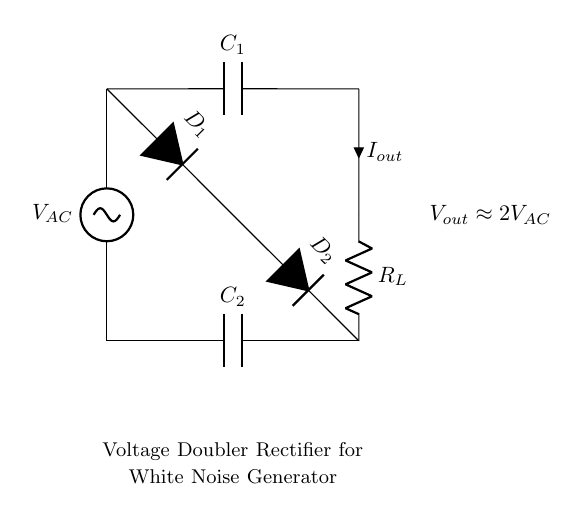What is the type of circuit represented? The circuit diagram shows a voltage doubler rectifier, which is designed to convert AC voltage to a higher DC voltage. The presence of capacitors and diodes with dual outputs indicates it's a specific type of rectifier that typically doubles the AC input voltage.
Answer: Voltage doubler rectifier What is the output voltage approximation? The output voltage is labeled as approximately twice the AC input voltage. This is derived from the function of the voltage doubler which, in ideal conditions, doubles the input voltage; hence, it is shown as two times the input AC voltage.
Answer: 2 times V AC How many capacitors are in the circuit? The circuit diagram contains two capacitors, labeled C1 and C2. Each capacitor serves a distinct purpose in the voltage doubling process, one connected to the output side and the other to the ground side of the circuit.
Answer: 2 What is the role of the diodes in this circuit? The diodes, labeled D1 and D2, allow current to flow in only one direction, enabling the rectification of the AC input to DC output. They prevent backflow, ensuring that the charge stored in the capacitors is used effectively for voltage doubling.
Answer: Rectification What does R L represent in the circuit? R L denotes the load resistor in the circuit, which is responsible for providing a path for the output current to flow. It represents the resistance that the white noise generator will see when powered from this circuit, affecting the output voltage and current.
Answer: Load resistor What would happen if C1 is removed from the circuit? If C1 is removed, the circuit cannot perform voltage doubling effectively. Capacitor C1 is critical for storing charge and maintaining the boosted output voltage; without it, the diodes would not function correctly, leading to reduced or unstable output voltage.
Answer: Voltage output drops 